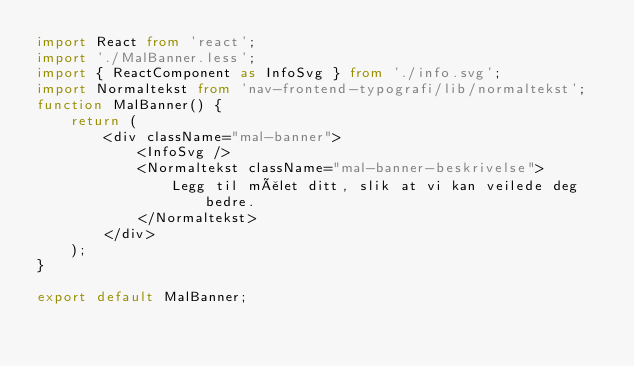<code> <loc_0><loc_0><loc_500><loc_500><_TypeScript_>import React from 'react';
import './MalBanner.less';
import { ReactComponent as InfoSvg } from './info.svg';
import Normaltekst from 'nav-frontend-typografi/lib/normaltekst';
function MalBanner() {
	return (
		<div className="mal-banner">
			<InfoSvg />
			<Normaltekst className="mal-banner-beskrivelse">
				Legg til målet ditt, slik at vi kan veilede deg bedre.
			</Normaltekst>
		</div>
	);
}

export default MalBanner;
</code> 